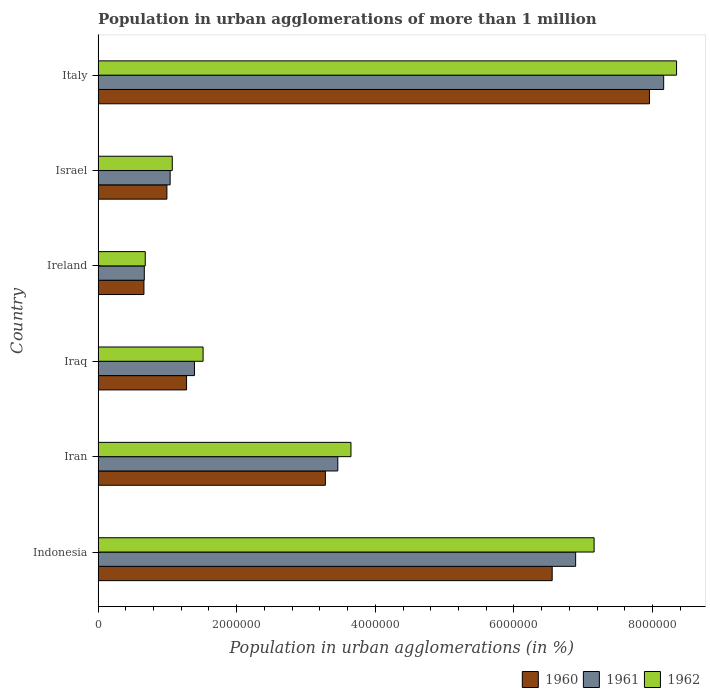How many different coloured bars are there?
Make the answer very short. 3. How many bars are there on the 1st tick from the top?
Make the answer very short. 3. What is the label of the 3rd group of bars from the top?
Offer a terse response. Ireland. In how many cases, is the number of bars for a given country not equal to the number of legend labels?
Your response must be concise. 0. What is the population in urban agglomerations in 1960 in Iran?
Your response must be concise. 3.28e+06. Across all countries, what is the maximum population in urban agglomerations in 1960?
Offer a very short reply. 7.96e+06. Across all countries, what is the minimum population in urban agglomerations in 1962?
Keep it short and to the point. 6.80e+05. In which country was the population in urban agglomerations in 1961 maximum?
Keep it short and to the point. Italy. In which country was the population in urban agglomerations in 1960 minimum?
Give a very brief answer. Ireland. What is the total population in urban agglomerations in 1962 in the graph?
Give a very brief answer. 2.24e+07. What is the difference between the population in urban agglomerations in 1962 in Indonesia and that in Italy?
Keep it short and to the point. -1.19e+06. What is the difference between the population in urban agglomerations in 1962 in Italy and the population in urban agglomerations in 1960 in Indonesia?
Provide a succinct answer. 1.79e+06. What is the average population in urban agglomerations in 1961 per country?
Provide a short and direct response. 3.60e+06. What is the difference between the population in urban agglomerations in 1962 and population in urban agglomerations in 1960 in Iraq?
Your answer should be very brief. 2.39e+05. In how many countries, is the population in urban agglomerations in 1962 greater than 1600000 %?
Offer a very short reply. 3. What is the ratio of the population in urban agglomerations in 1962 in Ireland to that in Israel?
Offer a terse response. 0.64. What is the difference between the highest and the second highest population in urban agglomerations in 1960?
Offer a very short reply. 1.40e+06. What is the difference between the highest and the lowest population in urban agglomerations in 1961?
Offer a very short reply. 7.50e+06. In how many countries, is the population in urban agglomerations in 1961 greater than the average population in urban agglomerations in 1961 taken over all countries?
Your answer should be compact. 2. Is the sum of the population in urban agglomerations in 1961 in Indonesia and Italy greater than the maximum population in urban agglomerations in 1962 across all countries?
Keep it short and to the point. Yes. What does the 3rd bar from the top in Ireland represents?
Make the answer very short. 1960. Is it the case that in every country, the sum of the population in urban agglomerations in 1960 and population in urban agglomerations in 1962 is greater than the population in urban agglomerations in 1961?
Offer a very short reply. Yes. How many countries are there in the graph?
Make the answer very short. 6. What is the difference between two consecutive major ticks on the X-axis?
Offer a terse response. 2.00e+06. Are the values on the major ticks of X-axis written in scientific E-notation?
Your answer should be very brief. No. Does the graph contain any zero values?
Keep it short and to the point. No. Does the graph contain grids?
Your response must be concise. No. How many legend labels are there?
Your response must be concise. 3. What is the title of the graph?
Provide a short and direct response. Population in urban agglomerations of more than 1 million. Does "2014" appear as one of the legend labels in the graph?
Offer a very short reply. No. What is the label or title of the X-axis?
Provide a succinct answer. Population in urban agglomerations (in %). What is the Population in urban agglomerations (in %) in 1960 in Indonesia?
Keep it short and to the point. 6.55e+06. What is the Population in urban agglomerations (in %) in 1961 in Indonesia?
Offer a very short reply. 6.89e+06. What is the Population in urban agglomerations (in %) of 1962 in Indonesia?
Your answer should be compact. 7.16e+06. What is the Population in urban agglomerations (in %) in 1960 in Iran?
Offer a terse response. 3.28e+06. What is the Population in urban agglomerations (in %) in 1961 in Iran?
Provide a succinct answer. 3.46e+06. What is the Population in urban agglomerations (in %) of 1962 in Iran?
Offer a terse response. 3.65e+06. What is the Population in urban agglomerations (in %) of 1960 in Iraq?
Your answer should be very brief. 1.28e+06. What is the Population in urban agglomerations (in %) in 1961 in Iraq?
Offer a very short reply. 1.39e+06. What is the Population in urban agglomerations (in %) in 1962 in Iraq?
Ensure brevity in your answer.  1.51e+06. What is the Population in urban agglomerations (in %) in 1960 in Ireland?
Make the answer very short. 6.61e+05. What is the Population in urban agglomerations (in %) of 1961 in Ireland?
Make the answer very short. 6.66e+05. What is the Population in urban agglomerations (in %) of 1962 in Ireland?
Your response must be concise. 6.80e+05. What is the Population in urban agglomerations (in %) in 1960 in Israel?
Provide a succinct answer. 9.93e+05. What is the Population in urban agglomerations (in %) in 1961 in Israel?
Provide a short and direct response. 1.04e+06. What is the Population in urban agglomerations (in %) in 1962 in Israel?
Give a very brief answer. 1.07e+06. What is the Population in urban agglomerations (in %) in 1960 in Italy?
Ensure brevity in your answer.  7.96e+06. What is the Population in urban agglomerations (in %) in 1961 in Italy?
Provide a succinct answer. 8.16e+06. What is the Population in urban agglomerations (in %) in 1962 in Italy?
Offer a very short reply. 8.35e+06. Across all countries, what is the maximum Population in urban agglomerations (in %) in 1960?
Keep it short and to the point. 7.96e+06. Across all countries, what is the maximum Population in urban agglomerations (in %) of 1961?
Ensure brevity in your answer.  8.16e+06. Across all countries, what is the maximum Population in urban agglomerations (in %) of 1962?
Offer a terse response. 8.35e+06. Across all countries, what is the minimum Population in urban agglomerations (in %) of 1960?
Your answer should be compact. 6.61e+05. Across all countries, what is the minimum Population in urban agglomerations (in %) of 1961?
Keep it short and to the point. 6.66e+05. Across all countries, what is the minimum Population in urban agglomerations (in %) in 1962?
Make the answer very short. 6.80e+05. What is the total Population in urban agglomerations (in %) in 1960 in the graph?
Offer a very short reply. 2.07e+07. What is the total Population in urban agglomerations (in %) in 1961 in the graph?
Your answer should be very brief. 2.16e+07. What is the total Population in urban agglomerations (in %) in 1962 in the graph?
Provide a succinct answer. 2.24e+07. What is the difference between the Population in urban agglomerations (in %) in 1960 in Indonesia and that in Iran?
Your answer should be very brief. 3.27e+06. What is the difference between the Population in urban agglomerations (in %) in 1961 in Indonesia and that in Iran?
Ensure brevity in your answer.  3.43e+06. What is the difference between the Population in urban agglomerations (in %) in 1962 in Indonesia and that in Iran?
Give a very brief answer. 3.51e+06. What is the difference between the Population in urban agglomerations (in %) in 1960 in Indonesia and that in Iraq?
Keep it short and to the point. 5.28e+06. What is the difference between the Population in urban agglomerations (in %) in 1961 in Indonesia and that in Iraq?
Ensure brevity in your answer.  5.50e+06. What is the difference between the Population in urban agglomerations (in %) of 1962 in Indonesia and that in Iraq?
Offer a very short reply. 5.64e+06. What is the difference between the Population in urban agglomerations (in %) in 1960 in Indonesia and that in Ireland?
Offer a very short reply. 5.89e+06. What is the difference between the Population in urban agglomerations (in %) in 1961 in Indonesia and that in Ireland?
Your response must be concise. 6.22e+06. What is the difference between the Population in urban agglomerations (in %) of 1962 in Indonesia and that in Ireland?
Offer a very short reply. 6.48e+06. What is the difference between the Population in urban agglomerations (in %) in 1960 in Indonesia and that in Israel?
Make the answer very short. 5.56e+06. What is the difference between the Population in urban agglomerations (in %) in 1961 in Indonesia and that in Israel?
Keep it short and to the point. 5.85e+06. What is the difference between the Population in urban agglomerations (in %) in 1962 in Indonesia and that in Israel?
Provide a succinct answer. 6.09e+06. What is the difference between the Population in urban agglomerations (in %) of 1960 in Indonesia and that in Italy?
Offer a very short reply. -1.40e+06. What is the difference between the Population in urban agglomerations (in %) in 1961 in Indonesia and that in Italy?
Your response must be concise. -1.27e+06. What is the difference between the Population in urban agglomerations (in %) in 1962 in Indonesia and that in Italy?
Your response must be concise. -1.19e+06. What is the difference between the Population in urban agglomerations (in %) of 1960 in Iran and that in Iraq?
Give a very brief answer. 2.00e+06. What is the difference between the Population in urban agglomerations (in %) of 1961 in Iran and that in Iraq?
Provide a succinct answer. 2.07e+06. What is the difference between the Population in urban agglomerations (in %) in 1962 in Iran and that in Iraq?
Provide a short and direct response. 2.13e+06. What is the difference between the Population in urban agglomerations (in %) in 1960 in Iran and that in Ireland?
Keep it short and to the point. 2.62e+06. What is the difference between the Population in urban agglomerations (in %) of 1961 in Iran and that in Ireland?
Give a very brief answer. 2.79e+06. What is the difference between the Population in urban agglomerations (in %) of 1962 in Iran and that in Ireland?
Your answer should be very brief. 2.97e+06. What is the difference between the Population in urban agglomerations (in %) of 1960 in Iran and that in Israel?
Give a very brief answer. 2.29e+06. What is the difference between the Population in urban agglomerations (in %) of 1961 in Iran and that in Israel?
Make the answer very short. 2.42e+06. What is the difference between the Population in urban agglomerations (in %) of 1962 in Iran and that in Israel?
Offer a very short reply. 2.58e+06. What is the difference between the Population in urban agglomerations (in %) of 1960 in Iran and that in Italy?
Your response must be concise. -4.68e+06. What is the difference between the Population in urban agglomerations (in %) of 1961 in Iran and that in Italy?
Make the answer very short. -4.70e+06. What is the difference between the Population in urban agglomerations (in %) in 1962 in Iran and that in Italy?
Your answer should be very brief. -4.70e+06. What is the difference between the Population in urban agglomerations (in %) of 1960 in Iraq and that in Ireland?
Keep it short and to the point. 6.15e+05. What is the difference between the Population in urban agglomerations (in %) in 1961 in Iraq and that in Ireland?
Keep it short and to the point. 7.24e+05. What is the difference between the Population in urban agglomerations (in %) of 1962 in Iraq and that in Ireland?
Keep it short and to the point. 8.35e+05. What is the difference between the Population in urban agglomerations (in %) in 1960 in Iraq and that in Israel?
Keep it short and to the point. 2.84e+05. What is the difference between the Population in urban agglomerations (in %) of 1961 in Iraq and that in Israel?
Offer a terse response. 3.51e+05. What is the difference between the Population in urban agglomerations (in %) in 1962 in Iraq and that in Israel?
Make the answer very short. 4.45e+05. What is the difference between the Population in urban agglomerations (in %) in 1960 in Iraq and that in Italy?
Your response must be concise. -6.68e+06. What is the difference between the Population in urban agglomerations (in %) of 1961 in Iraq and that in Italy?
Your answer should be very brief. -6.77e+06. What is the difference between the Population in urban agglomerations (in %) in 1962 in Iraq and that in Italy?
Your answer should be compact. -6.83e+06. What is the difference between the Population in urban agglomerations (in %) of 1960 in Ireland and that in Israel?
Give a very brief answer. -3.32e+05. What is the difference between the Population in urban agglomerations (in %) in 1961 in Ireland and that in Israel?
Make the answer very short. -3.73e+05. What is the difference between the Population in urban agglomerations (in %) of 1962 in Ireland and that in Israel?
Make the answer very short. -3.90e+05. What is the difference between the Population in urban agglomerations (in %) of 1960 in Ireland and that in Italy?
Offer a terse response. -7.30e+06. What is the difference between the Population in urban agglomerations (in %) in 1961 in Ireland and that in Italy?
Ensure brevity in your answer.  -7.50e+06. What is the difference between the Population in urban agglomerations (in %) in 1962 in Ireland and that in Italy?
Offer a terse response. -7.67e+06. What is the difference between the Population in urban agglomerations (in %) in 1960 in Israel and that in Italy?
Keep it short and to the point. -6.96e+06. What is the difference between the Population in urban agglomerations (in %) in 1961 in Israel and that in Italy?
Provide a short and direct response. -7.12e+06. What is the difference between the Population in urban agglomerations (in %) of 1962 in Israel and that in Italy?
Provide a short and direct response. -7.28e+06. What is the difference between the Population in urban agglomerations (in %) of 1960 in Indonesia and the Population in urban agglomerations (in %) of 1961 in Iran?
Ensure brevity in your answer.  3.09e+06. What is the difference between the Population in urban agglomerations (in %) in 1960 in Indonesia and the Population in urban agglomerations (in %) in 1962 in Iran?
Your answer should be compact. 2.90e+06. What is the difference between the Population in urban agglomerations (in %) in 1961 in Indonesia and the Population in urban agglomerations (in %) in 1962 in Iran?
Your response must be concise. 3.24e+06. What is the difference between the Population in urban agglomerations (in %) of 1960 in Indonesia and the Population in urban agglomerations (in %) of 1961 in Iraq?
Keep it short and to the point. 5.16e+06. What is the difference between the Population in urban agglomerations (in %) in 1960 in Indonesia and the Population in urban agglomerations (in %) in 1962 in Iraq?
Make the answer very short. 5.04e+06. What is the difference between the Population in urban agglomerations (in %) in 1961 in Indonesia and the Population in urban agglomerations (in %) in 1962 in Iraq?
Your answer should be compact. 5.38e+06. What is the difference between the Population in urban agglomerations (in %) of 1960 in Indonesia and the Population in urban agglomerations (in %) of 1961 in Ireland?
Offer a very short reply. 5.89e+06. What is the difference between the Population in urban agglomerations (in %) in 1960 in Indonesia and the Population in urban agglomerations (in %) in 1962 in Ireland?
Provide a succinct answer. 5.87e+06. What is the difference between the Population in urban agglomerations (in %) of 1961 in Indonesia and the Population in urban agglomerations (in %) of 1962 in Ireland?
Your answer should be very brief. 6.21e+06. What is the difference between the Population in urban agglomerations (in %) in 1960 in Indonesia and the Population in urban agglomerations (in %) in 1961 in Israel?
Ensure brevity in your answer.  5.51e+06. What is the difference between the Population in urban agglomerations (in %) of 1960 in Indonesia and the Population in urban agglomerations (in %) of 1962 in Israel?
Ensure brevity in your answer.  5.48e+06. What is the difference between the Population in urban agglomerations (in %) of 1961 in Indonesia and the Population in urban agglomerations (in %) of 1962 in Israel?
Give a very brief answer. 5.82e+06. What is the difference between the Population in urban agglomerations (in %) in 1960 in Indonesia and the Population in urban agglomerations (in %) in 1961 in Italy?
Provide a short and direct response. -1.61e+06. What is the difference between the Population in urban agglomerations (in %) of 1960 in Indonesia and the Population in urban agglomerations (in %) of 1962 in Italy?
Offer a very short reply. -1.79e+06. What is the difference between the Population in urban agglomerations (in %) of 1961 in Indonesia and the Population in urban agglomerations (in %) of 1962 in Italy?
Your answer should be compact. -1.46e+06. What is the difference between the Population in urban agglomerations (in %) in 1960 in Iran and the Population in urban agglomerations (in %) in 1961 in Iraq?
Your answer should be very brief. 1.89e+06. What is the difference between the Population in urban agglomerations (in %) of 1960 in Iran and the Population in urban agglomerations (in %) of 1962 in Iraq?
Give a very brief answer. 1.76e+06. What is the difference between the Population in urban agglomerations (in %) in 1961 in Iran and the Population in urban agglomerations (in %) in 1962 in Iraq?
Your answer should be very brief. 1.94e+06. What is the difference between the Population in urban agglomerations (in %) in 1960 in Iran and the Population in urban agglomerations (in %) in 1961 in Ireland?
Your answer should be compact. 2.61e+06. What is the difference between the Population in urban agglomerations (in %) in 1960 in Iran and the Population in urban agglomerations (in %) in 1962 in Ireland?
Offer a very short reply. 2.60e+06. What is the difference between the Population in urban agglomerations (in %) in 1961 in Iran and the Population in urban agglomerations (in %) in 1962 in Ireland?
Your response must be concise. 2.78e+06. What is the difference between the Population in urban agglomerations (in %) of 1960 in Iran and the Population in urban agglomerations (in %) of 1961 in Israel?
Give a very brief answer. 2.24e+06. What is the difference between the Population in urban agglomerations (in %) of 1960 in Iran and the Population in urban agglomerations (in %) of 1962 in Israel?
Your answer should be very brief. 2.21e+06. What is the difference between the Population in urban agglomerations (in %) in 1961 in Iran and the Population in urban agglomerations (in %) in 1962 in Israel?
Keep it short and to the point. 2.39e+06. What is the difference between the Population in urban agglomerations (in %) of 1960 in Iran and the Population in urban agglomerations (in %) of 1961 in Italy?
Make the answer very short. -4.88e+06. What is the difference between the Population in urban agglomerations (in %) in 1960 in Iran and the Population in urban agglomerations (in %) in 1962 in Italy?
Provide a succinct answer. -5.07e+06. What is the difference between the Population in urban agglomerations (in %) of 1961 in Iran and the Population in urban agglomerations (in %) of 1962 in Italy?
Your response must be concise. -4.89e+06. What is the difference between the Population in urban agglomerations (in %) of 1960 in Iraq and the Population in urban agglomerations (in %) of 1961 in Ireland?
Ensure brevity in your answer.  6.10e+05. What is the difference between the Population in urban agglomerations (in %) of 1960 in Iraq and the Population in urban agglomerations (in %) of 1962 in Ireland?
Offer a very short reply. 5.96e+05. What is the difference between the Population in urban agglomerations (in %) in 1961 in Iraq and the Population in urban agglomerations (in %) in 1962 in Ireland?
Provide a short and direct response. 7.10e+05. What is the difference between the Population in urban agglomerations (in %) of 1960 in Iraq and the Population in urban agglomerations (in %) of 1961 in Israel?
Offer a terse response. 2.37e+05. What is the difference between the Population in urban agglomerations (in %) of 1960 in Iraq and the Population in urban agglomerations (in %) of 1962 in Israel?
Provide a succinct answer. 2.06e+05. What is the difference between the Population in urban agglomerations (in %) of 1961 in Iraq and the Population in urban agglomerations (in %) of 1962 in Israel?
Offer a terse response. 3.20e+05. What is the difference between the Population in urban agglomerations (in %) of 1960 in Iraq and the Population in urban agglomerations (in %) of 1961 in Italy?
Your answer should be compact. -6.89e+06. What is the difference between the Population in urban agglomerations (in %) in 1960 in Iraq and the Population in urban agglomerations (in %) in 1962 in Italy?
Ensure brevity in your answer.  -7.07e+06. What is the difference between the Population in urban agglomerations (in %) in 1961 in Iraq and the Population in urban agglomerations (in %) in 1962 in Italy?
Provide a short and direct response. -6.96e+06. What is the difference between the Population in urban agglomerations (in %) in 1960 in Ireland and the Population in urban agglomerations (in %) in 1961 in Israel?
Offer a terse response. -3.78e+05. What is the difference between the Population in urban agglomerations (in %) in 1960 in Ireland and the Population in urban agglomerations (in %) in 1962 in Israel?
Keep it short and to the point. -4.09e+05. What is the difference between the Population in urban agglomerations (in %) in 1961 in Ireland and the Population in urban agglomerations (in %) in 1962 in Israel?
Provide a succinct answer. -4.04e+05. What is the difference between the Population in urban agglomerations (in %) in 1960 in Ireland and the Population in urban agglomerations (in %) in 1961 in Italy?
Provide a succinct answer. -7.50e+06. What is the difference between the Population in urban agglomerations (in %) in 1960 in Ireland and the Population in urban agglomerations (in %) in 1962 in Italy?
Ensure brevity in your answer.  -7.69e+06. What is the difference between the Population in urban agglomerations (in %) in 1961 in Ireland and the Population in urban agglomerations (in %) in 1962 in Italy?
Offer a terse response. -7.68e+06. What is the difference between the Population in urban agglomerations (in %) of 1960 in Israel and the Population in urban agglomerations (in %) of 1961 in Italy?
Your answer should be very brief. -7.17e+06. What is the difference between the Population in urban agglomerations (in %) of 1960 in Israel and the Population in urban agglomerations (in %) of 1962 in Italy?
Give a very brief answer. -7.36e+06. What is the difference between the Population in urban agglomerations (in %) of 1961 in Israel and the Population in urban agglomerations (in %) of 1962 in Italy?
Your answer should be very brief. -7.31e+06. What is the average Population in urban agglomerations (in %) in 1960 per country?
Your answer should be compact. 3.45e+06. What is the average Population in urban agglomerations (in %) in 1961 per country?
Provide a short and direct response. 3.60e+06. What is the average Population in urban agglomerations (in %) of 1962 per country?
Keep it short and to the point. 3.74e+06. What is the difference between the Population in urban agglomerations (in %) of 1960 and Population in urban agglomerations (in %) of 1961 in Indonesia?
Keep it short and to the point. -3.38e+05. What is the difference between the Population in urban agglomerations (in %) in 1960 and Population in urban agglomerations (in %) in 1962 in Indonesia?
Offer a very short reply. -6.05e+05. What is the difference between the Population in urban agglomerations (in %) of 1961 and Population in urban agglomerations (in %) of 1962 in Indonesia?
Offer a very short reply. -2.67e+05. What is the difference between the Population in urban agglomerations (in %) in 1960 and Population in urban agglomerations (in %) in 1961 in Iran?
Your answer should be very brief. -1.79e+05. What is the difference between the Population in urban agglomerations (in %) of 1960 and Population in urban agglomerations (in %) of 1962 in Iran?
Your answer should be very brief. -3.69e+05. What is the difference between the Population in urban agglomerations (in %) of 1961 and Population in urban agglomerations (in %) of 1962 in Iran?
Keep it short and to the point. -1.90e+05. What is the difference between the Population in urban agglomerations (in %) of 1960 and Population in urban agglomerations (in %) of 1961 in Iraq?
Your response must be concise. -1.14e+05. What is the difference between the Population in urban agglomerations (in %) in 1960 and Population in urban agglomerations (in %) in 1962 in Iraq?
Offer a terse response. -2.39e+05. What is the difference between the Population in urban agglomerations (in %) of 1961 and Population in urban agglomerations (in %) of 1962 in Iraq?
Provide a succinct answer. -1.25e+05. What is the difference between the Population in urban agglomerations (in %) of 1960 and Population in urban agglomerations (in %) of 1961 in Ireland?
Provide a short and direct response. -5272. What is the difference between the Population in urban agglomerations (in %) of 1960 and Population in urban agglomerations (in %) of 1962 in Ireland?
Offer a very short reply. -1.90e+04. What is the difference between the Population in urban agglomerations (in %) of 1961 and Population in urban agglomerations (in %) of 1962 in Ireland?
Your response must be concise. -1.37e+04. What is the difference between the Population in urban agglomerations (in %) of 1960 and Population in urban agglomerations (in %) of 1961 in Israel?
Give a very brief answer. -4.66e+04. What is the difference between the Population in urban agglomerations (in %) in 1960 and Population in urban agglomerations (in %) in 1962 in Israel?
Offer a terse response. -7.73e+04. What is the difference between the Population in urban agglomerations (in %) in 1961 and Population in urban agglomerations (in %) in 1962 in Israel?
Offer a very short reply. -3.06e+04. What is the difference between the Population in urban agglomerations (in %) of 1960 and Population in urban agglomerations (in %) of 1961 in Italy?
Provide a short and direct response. -2.05e+05. What is the difference between the Population in urban agglomerations (in %) of 1960 and Population in urban agglomerations (in %) of 1962 in Italy?
Your response must be concise. -3.91e+05. What is the difference between the Population in urban agglomerations (in %) of 1961 and Population in urban agglomerations (in %) of 1962 in Italy?
Offer a very short reply. -1.86e+05. What is the ratio of the Population in urban agglomerations (in %) in 1960 in Indonesia to that in Iran?
Ensure brevity in your answer.  2. What is the ratio of the Population in urban agglomerations (in %) in 1961 in Indonesia to that in Iran?
Offer a very short reply. 1.99. What is the ratio of the Population in urban agglomerations (in %) in 1962 in Indonesia to that in Iran?
Keep it short and to the point. 1.96. What is the ratio of the Population in urban agglomerations (in %) of 1960 in Indonesia to that in Iraq?
Your answer should be compact. 5.13. What is the ratio of the Population in urban agglomerations (in %) in 1961 in Indonesia to that in Iraq?
Ensure brevity in your answer.  4.96. What is the ratio of the Population in urban agglomerations (in %) of 1962 in Indonesia to that in Iraq?
Give a very brief answer. 4.73. What is the ratio of the Population in urban agglomerations (in %) of 1960 in Indonesia to that in Ireland?
Make the answer very short. 9.91. What is the ratio of the Population in urban agglomerations (in %) of 1961 in Indonesia to that in Ireland?
Keep it short and to the point. 10.34. What is the ratio of the Population in urban agglomerations (in %) in 1962 in Indonesia to that in Ireland?
Offer a terse response. 10.52. What is the ratio of the Population in urban agglomerations (in %) of 1960 in Indonesia to that in Israel?
Provide a short and direct response. 6.6. What is the ratio of the Population in urban agglomerations (in %) of 1961 in Indonesia to that in Israel?
Provide a succinct answer. 6.63. What is the ratio of the Population in urban agglomerations (in %) of 1962 in Indonesia to that in Israel?
Keep it short and to the point. 6.69. What is the ratio of the Population in urban agglomerations (in %) in 1960 in Indonesia to that in Italy?
Your answer should be very brief. 0.82. What is the ratio of the Population in urban agglomerations (in %) in 1961 in Indonesia to that in Italy?
Keep it short and to the point. 0.84. What is the ratio of the Population in urban agglomerations (in %) of 1962 in Indonesia to that in Italy?
Offer a very short reply. 0.86. What is the ratio of the Population in urban agglomerations (in %) in 1960 in Iran to that in Iraq?
Offer a terse response. 2.57. What is the ratio of the Population in urban agglomerations (in %) in 1961 in Iran to that in Iraq?
Your response must be concise. 2.49. What is the ratio of the Population in urban agglomerations (in %) in 1962 in Iran to that in Iraq?
Your response must be concise. 2.41. What is the ratio of the Population in urban agglomerations (in %) in 1960 in Iran to that in Ireland?
Provide a short and direct response. 4.96. What is the ratio of the Population in urban agglomerations (in %) in 1961 in Iran to that in Ireland?
Provide a succinct answer. 5.19. What is the ratio of the Population in urban agglomerations (in %) in 1962 in Iran to that in Ireland?
Your response must be concise. 5.36. What is the ratio of the Population in urban agglomerations (in %) of 1960 in Iran to that in Israel?
Your answer should be very brief. 3.3. What is the ratio of the Population in urban agglomerations (in %) of 1961 in Iran to that in Israel?
Make the answer very short. 3.33. What is the ratio of the Population in urban agglomerations (in %) in 1962 in Iran to that in Israel?
Offer a very short reply. 3.41. What is the ratio of the Population in urban agglomerations (in %) of 1960 in Iran to that in Italy?
Your response must be concise. 0.41. What is the ratio of the Population in urban agglomerations (in %) in 1961 in Iran to that in Italy?
Ensure brevity in your answer.  0.42. What is the ratio of the Population in urban agglomerations (in %) of 1962 in Iran to that in Italy?
Provide a short and direct response. 0.44. What is the ratio of the Population in urban agglomerations (in %) of 1960 in Iraq to that in Ireland?
Offer a very short reply. 1.93. What is the ratio of the Population in urban agglomerations (in %) of 1961 in Iraq to that in Ireland?
Your answer should be very brief. 2.09. What is the ratio of the Population in urban agglomerations (in %) in 1962 in Iraq to that in Ireland?
Your answer should be very brief. 2.23. What is the ratio of the Population in urban agglomerations (in %) of 1960 in Iraq to that in Israel?
Give a very brief answer. 1.29. What is the ratio of the Population in urban agglomerations (in %) in 1961 in Iraq to that in Israel?
Provide a short and direct response. 1.34. What is the ratio of the Population in urban agglomerations (in %) of 1962 in Iraq to that in Israel?
Offer a terse response. 1.42. What is the ratio of the Population in urban agglomerations (in %) of 1960 in Iraq to that in Italy?
Keep it short and to the point. 0.16. What is the ratio of the Population in urban agglomerations (in %) of 1961 in Iraq to that in Italy?
Provide a short and direct response. 0.17. What is the ratio of the Population in urban agglomerations (in %) in 1962 in Iraq to that in Italy?
Your answer should be very brief. 0.18. What is the ratio of the Population in urban agglomerations (in %) of 1960 in Ireland to that in Israel?
Keep it short and to the point. 0.67. What is the ratio of the Population in urban agglomerations (in %) in 1961 in Ireland to that in Israel?
Give a very brief answer. 0.64. What is the ratio of the Population in urban agglomerations (in %) of 1962 in Ireland to that in Israel?
Your response must be concise. 0.64. What is the ratio of the Population in urban agglomerations (in %) in 1960 in Ireland to that in Italy?
Keep it short and to the point. 0.08. What is the ratio of the Population in urban agglomerations (in %) in 1961 in Ireland to that in Italy?
Keep it short and to the point. 0.08. What is the ratio of the Population in urban agglomerations (in %) of 1962 in Ireland to that in Italy?
Keep it short and to the point. 0.08. What is the ratio of the Population in urban agglomerations (in %) of 1960 in Israel to that in Italy?
Make the answer very short. 0.12. What is the ratio of the Population in urban agglomerations (in %) of 1961 in Israel to that in Italy?
Your answer should be compact. 0.13. What is the ratio of the Population in urban agglomerations (in %) in 1962 in Israel to that in Italy?
Your response must be concise. 0.13. What is the difference between the highest and the second highest Population in urban agglomerations (in %) in 1960?
Your answer should be compact. 1.40e+06. What is the difference between the highest and the second highest Population in urban agglomerations (in %) of 1961?
Give a very brief answer. 1.27e+06. What is the difference between the highest and the second highest Population in urban agglomerations (in %) of 1962?
Your answer should be compact. 1.19e+06. What is the difference between the highest and the lowest Population in urban agglomerations (in %) in 1960?
Provide a short and direct response. 7.30e+06. What is the difference between the highest and the lowest Population in urban agglomerations (in %) in 1961?
Provide a short and direct response. 7.50e+06. What is the difference between the highest and the lowest Population in urban agglomerations (in %) in 1962?
Provide a succinct answer. 7.67e+06. 